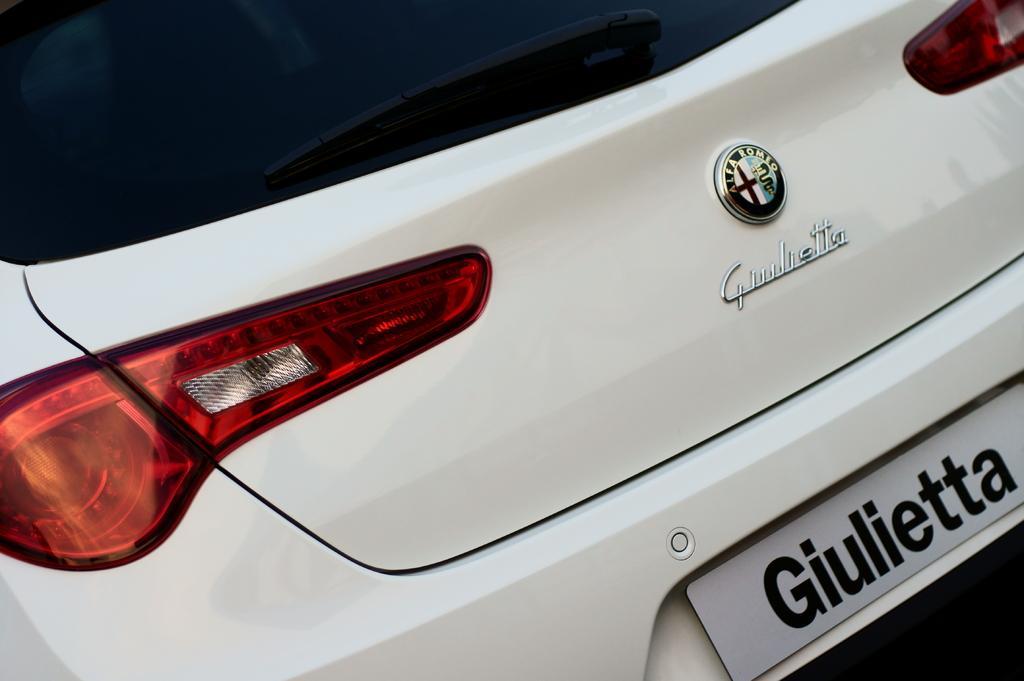Could you give a brief overview of what you see in this image? There is a white color vehicle having red, white and yellow color lights, a logo on the dickey door and there is a name plate. 